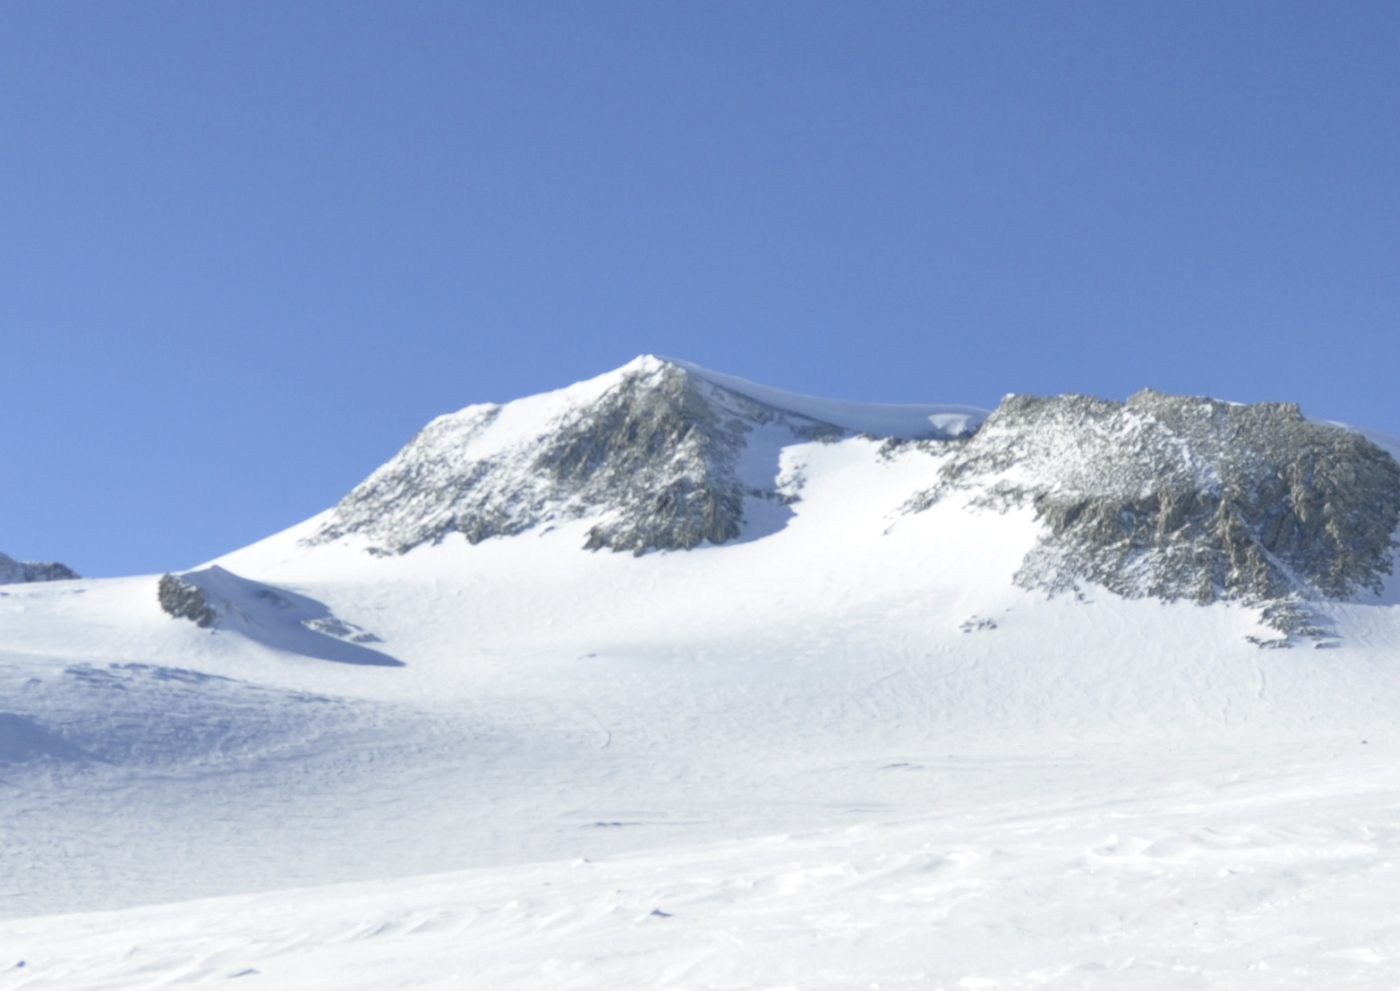What's happening in the scene? The image depicts Vinson Massif, the tallest peak in Antarctica. Cloaked in a thick layer of snow and ice, it rises majestically against a backdrop of clear blue sky. The perspective is from a lower vantage point looking upwards, which amplifies the peak’s impressive height and grandeur. The terrain is a mix of pristine white snow and exposed rock, painted in shades of gray and black. The overall scene captures the raw beauty and severe conditions of the Antarctic wilderness, highlighting the untouched and pristine nature of this remote environment. 